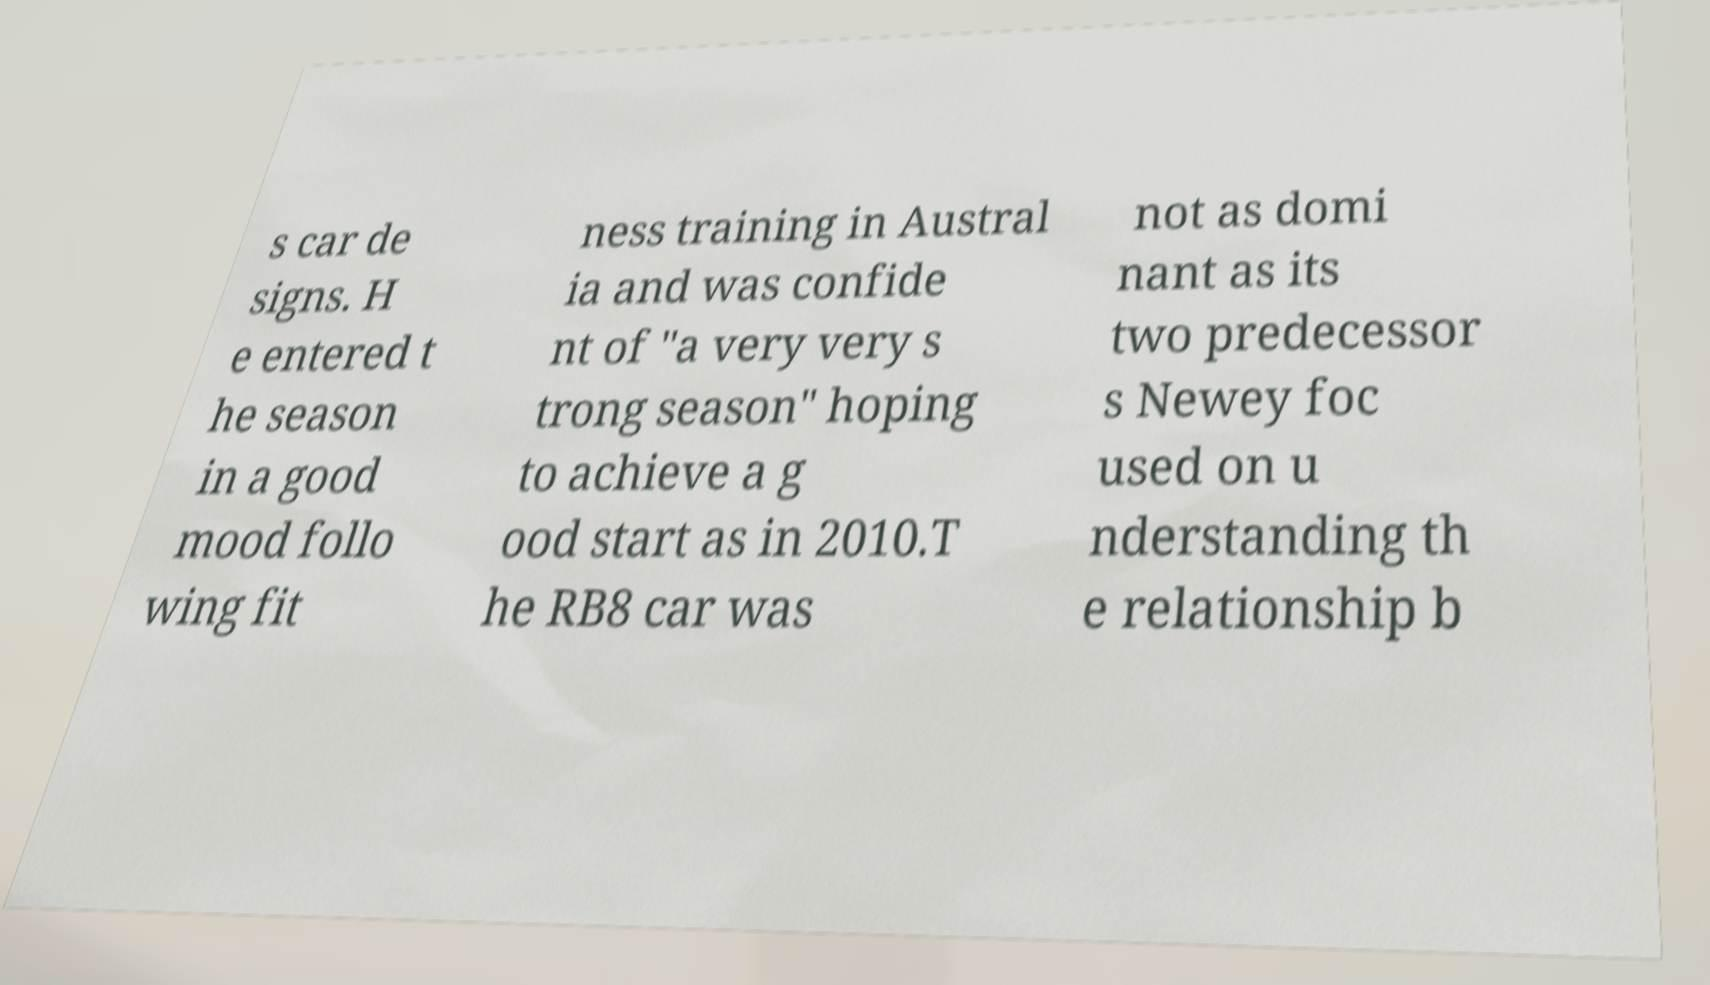Could you assist in decoding the text presented in this image and type it out clearly? s car de signs. H e entered t he season in a good mood follo wing fit ness training in Austral ia and was confide nt of "a very very s trong season" hoping to achieve a g ood start as in 2010.T he RB8 car was not as domi nant as its two predecessor s Newey foc used on u nderstanding th e relationship b 